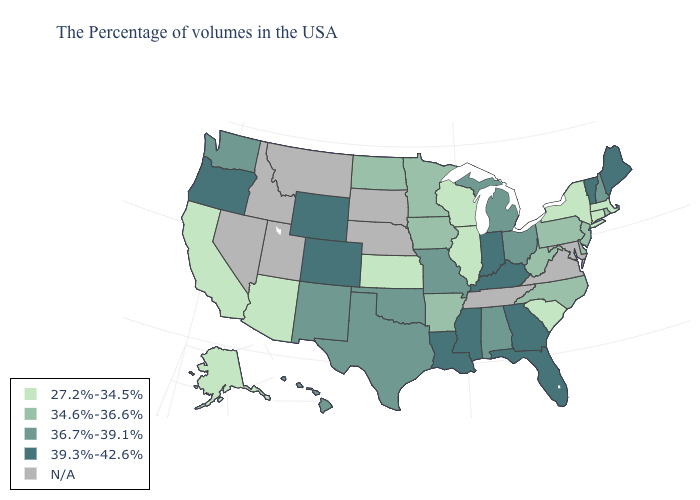Name the states that have a value in the range 34.6%-36.6%?
Be succinct. Rhode Island, New Jersey, Delaware, Pennsylvania, North Carolina, West Virginia, Arkansas, Minnesota, Iowa, North Dakota. What is the value of Virginia?
Short answer required. N/A. Name the states that have a value in the range 34.6%-36.6%?
Write a very short answer. Rhode Island, New Jersey, Delaware, Pennsylvania, North Carolina, West Virginia, Arkansas, Minnesota, Iowa, North Dakota. What is the value of Idaho?
Answer briefly. N/A. Name the states that have a value in the range 34.6%-36.6%?
Short answer required. Rhode Island, New Jersey, Delaware, Pennsylvania, North Carolina, West Virginia, Arkansas, Minnesota, Iowa, North Dakota. What is the value of Kansas?
Quick response, please. 27.2%-34.5%. Name the states that have a value in the range 39.3%-42.6%?
Give a very brief answer. Maine, Vermont, Florida, Georgia, Kentucky, Indiana, Mississippi, Louisiana, Wyoming, Colorado, Oregon. What is the highest value in the USA?
Keep it brief. 39.3%-42.6%. Name the states that have a value in the range 27.2%-34.5%?
Be succinct. Massachusetts, Connecticut, New York, South Carolina, Wisconsin, Illinois, Kansas, Arizona, California, Alaska. Name the states that have a value in the range 39.3%-42.6%?
Give a very brief answer. Maine, Vermont, Florida, Georgia, Kentucky, Indiana, Mississippi, Louisiana, Wyoming, Colorado, Oregon. Is the legend a continuous bar?
Answer briefly. No. Does the first symbol in the legend represent the smallest category?
Concise answer only. Yes. Does Indiana have the highest value in the MidWest?
Keep it brief. Yes. 